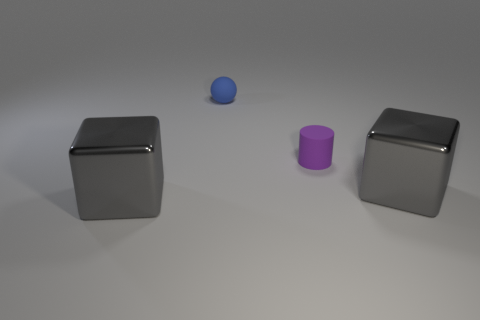Are there any other things that have the same shape as the small purple object?
Provide a succinct answer. No. How many big gray blocks have the same material as the purple cylinder?
Give a very brief answer. 0. There is a purple cylinder that is to the left of the metal object on the right side of the rubber ball; is there a blue matte ball on the right side of it?
Provide a succinct answer. No. What shape is the blue matte object?
Provide a succinct answer. Sphere. Are the gray object that is on the left side of the purple object and the small object that is in front of the blue sphere made of the same material?
Offer a very short reply. No. What number of other cylinders have the same color as the cylinder?
Offer a very short reply. 0. The thing that is both in front of the blue rubber object and on the left side of the rubber cylinder has what shape?
Your response must be concise. Cube. What color is the thing that is in front of the purple cylinder and on the right side of the tiny blue rubber ball?
Your answer should be compact. Gray. Are there more gray shiny blocks right of the cylinder than gray objects that are behind the tiny blue matte thing?
Ensure brevity in your answer.  Yes. There is a block on the right side of the tiny matte cylinder; what color is it?
Your response must be concise. Gray. 